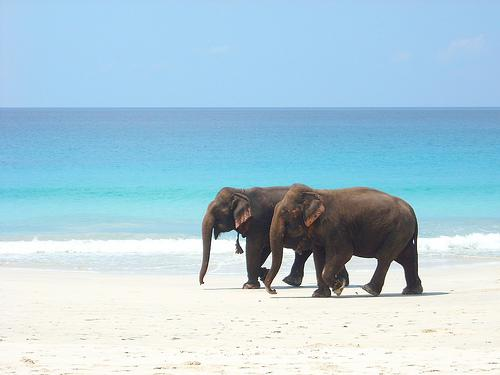Question: who owns these elephants?
Choices:
A. The zoo.
B. The animal trainer.
C. The state.
D. The circus.
Answer with the letter. Answer: B Question: what type of animals are these?
Choices:
A. Horses.
B. Zebras.
C. Goats.
D. Elephants.
Answer with the letter. Answer: D Question: what color are the elephants?
Choices:
A. Black.
B. White.
C. Brown.
D. Grey.
Answer with the letter. Answer: D Question: how many elephants are in this photo?
Choices:
A. One.
B. Two.
C. Three.
D. Four.
Answer with the letter. Answer: B 